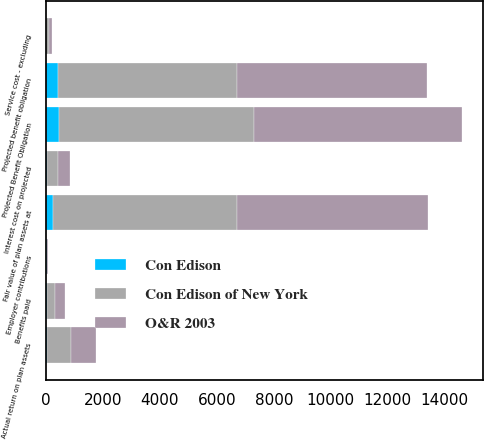Convert chart. <chart><loc_0><loc_0><loc_500><loc_500><stacked_bar_chart><ecel><fcel>Projected benefit obligation<fcel>Service cost - excluding<fcel>Interest cost on projected<fcel>Projected Benefit Obligation<fcel>Fair value of plan assets at<fcel>Actual return on plan assets<fcel>Employer contributions<fcel>Benefits paid<nl><fcel>O&R 2003<fcel>6695<fcel>104<fcel>414<fcel>7315<fcel>6710<fcel>872<fcel>28<fcel>330<nl><fcel>Con Edison of New York<fcel>6267<fcel>96<fcel>388<fcel>6840<fcel>6474<fcel>840<fcel>2<fcel>306<nl><fcel>Con Edison<fcel>425<fcel>8<fcel>26<fcel>471<fcel>236<fcel>32<fcel>24<fcel>24<nl></chart> 